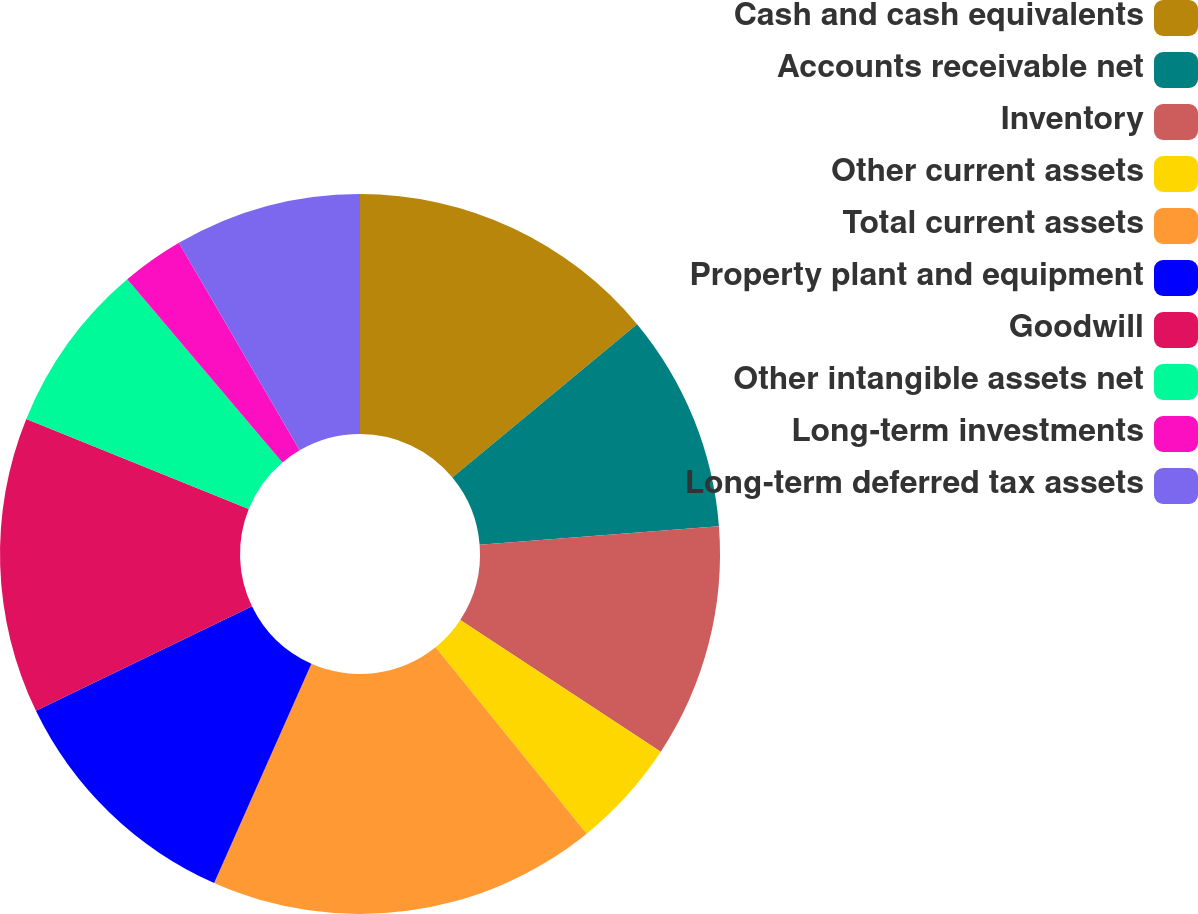Convert chart to OTSL. <chart><loc_0><loc_0><loc_500><loc_500><pie_chart><fcel>Cash and cash equivalents<fcel>Accounts receivable net<fcel>Inventory<fcel>Other current assets<fcel>Total current assets<fcel>Property plant and equipment<fcel>Goodwill<fcel>Other intangible assets net<fcel>Long-term investments<fcel>Long-term deferred tax assets<nl><fcel>13.98%<fcel>9.79%<fcel>10.49%<fcel>4.9%<fcel>17.48%<fcel>11.19%<fcel>13.29%<fcel>7.69%<fcel>2.8%<fcel>8.39%<nl></chart> 